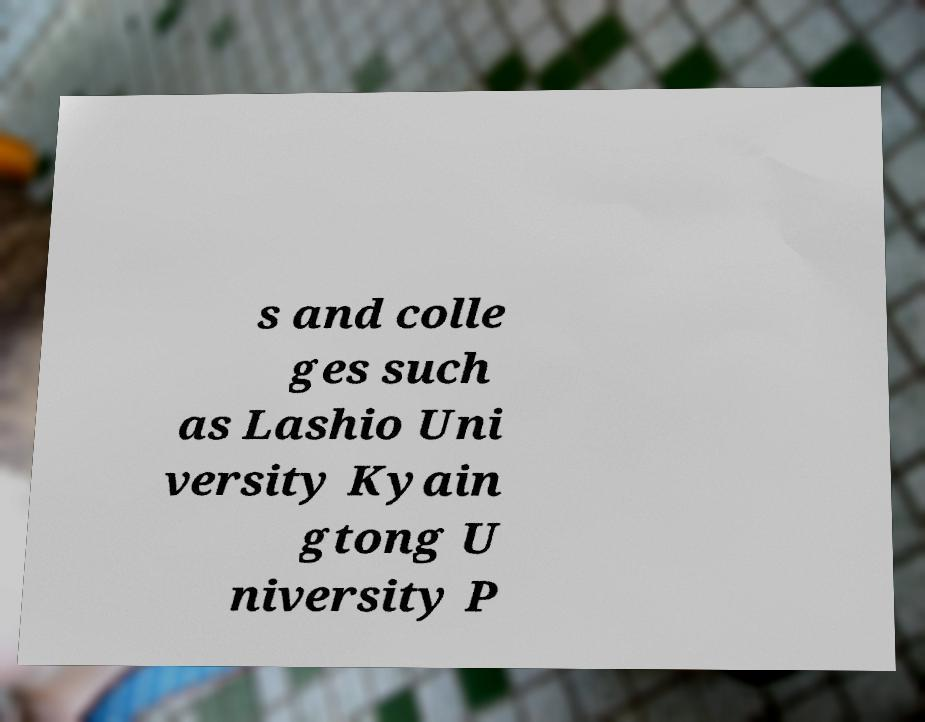Can you accurately transcribe the text from the provided image for me? s and colle ges such as Lashio Uni versity Kyain gtong U niversity P 